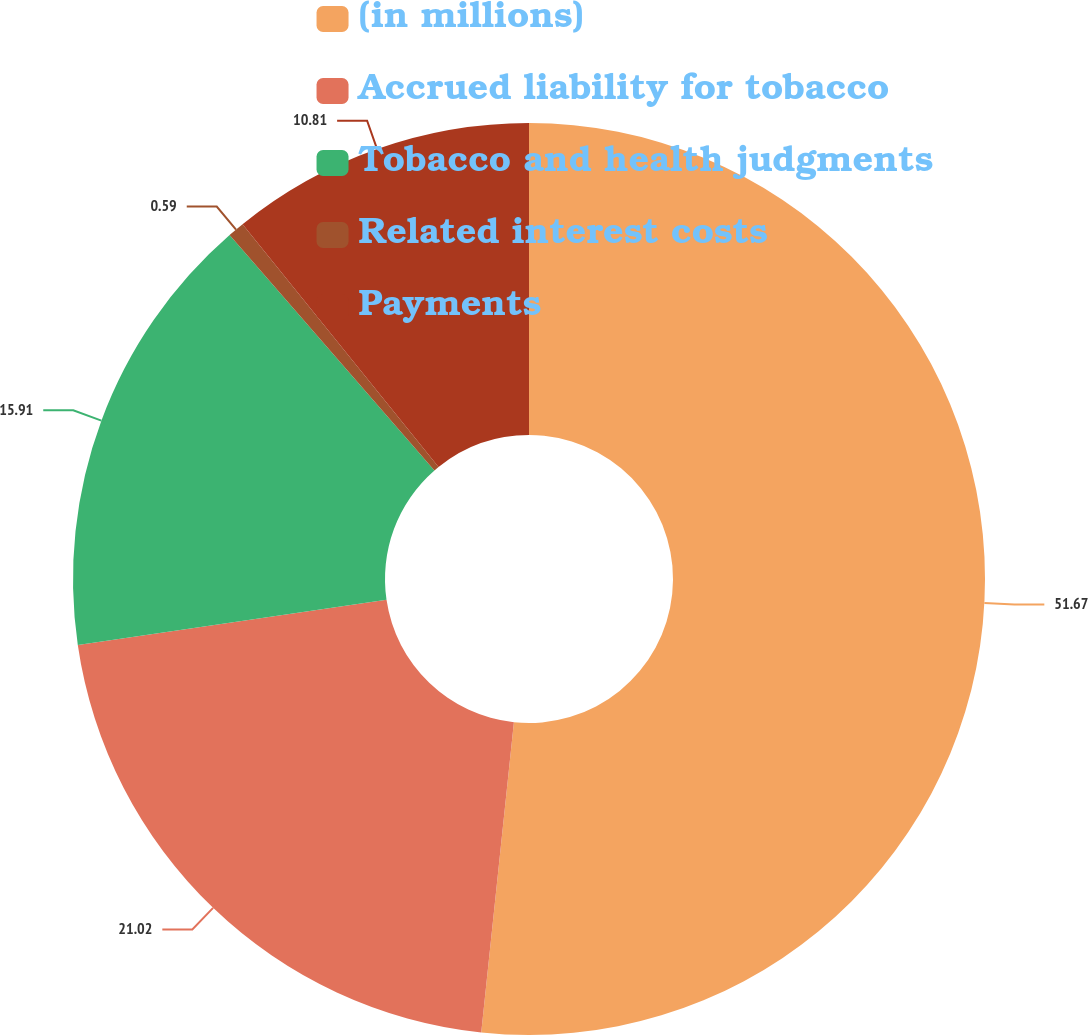<chart> <loc_0><loc_0><loc_500><loc_500><pie_chart><fcel>(in millions)<fcel>Accrued liability for tobacco<fcel>Tobacco and health judgments<fcel>Related interest costs<fcel>Payments<nl><fcel>51.67%<fcel>21.02%<fcel>15.91%<fcel>0.59%<fcel>10.81%<nl></chart> 